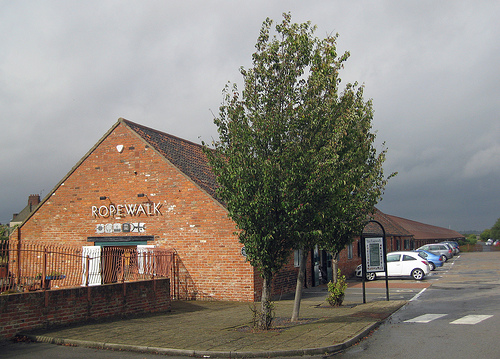<image>
Can you confirm if the car is behind the tree? Yes. From this viewpoint, the car is positioned behind the tree, with the tree partially or fully occluding the car. Is there a sign in front of the wall? No. The sign is not in front of the wall. The spatial positioning shows a different relationship between these objects. 